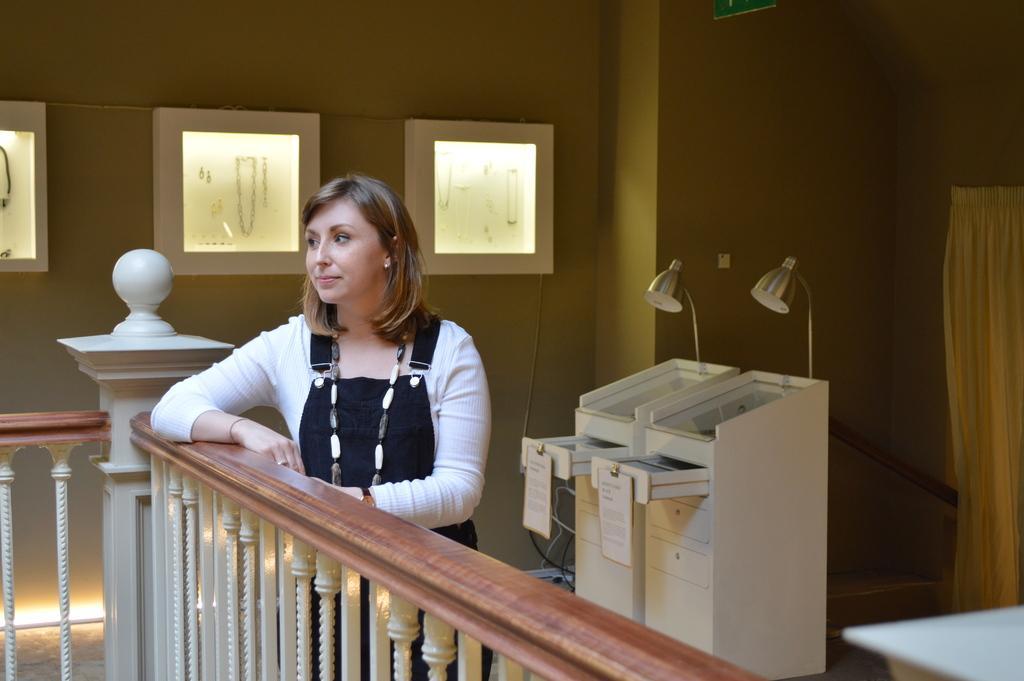In one or two sentences, can you explain what this image depicts? In this image I see a woman who is standing and in the background I see the wall and few jewelry in the boxes. 